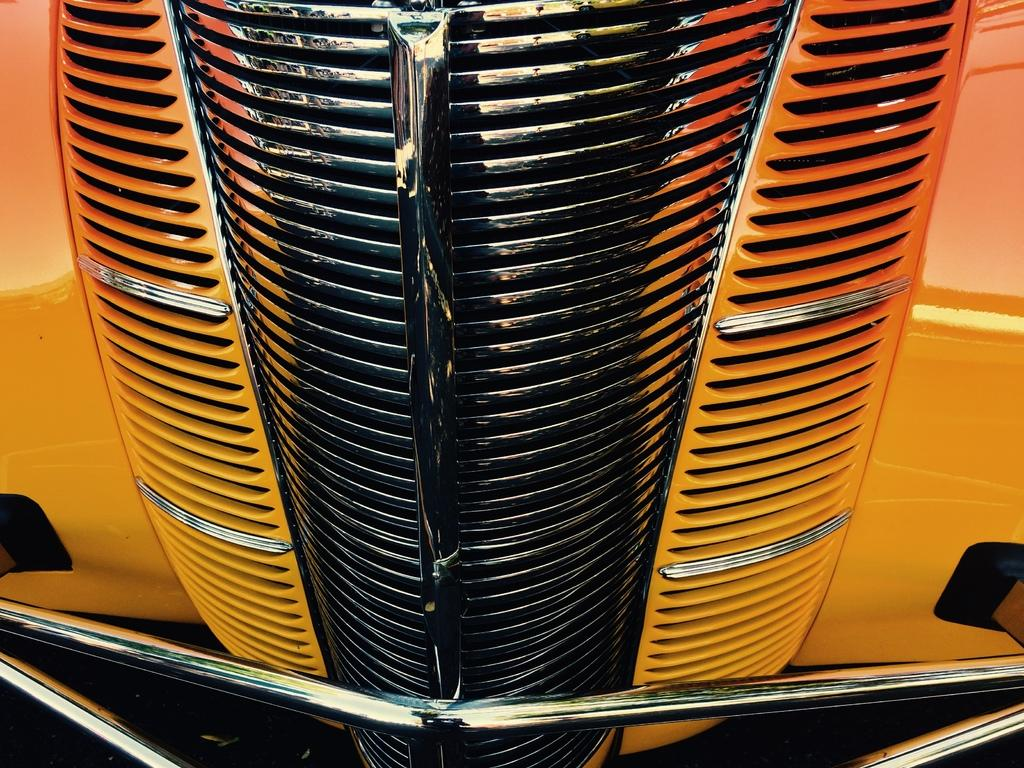What part of a car is visible in the image? There is a hood of a car in the image. Can you see a pig swimming in the lake in the image? There is no lake or pig present in the image; it only features the hood of a car. 